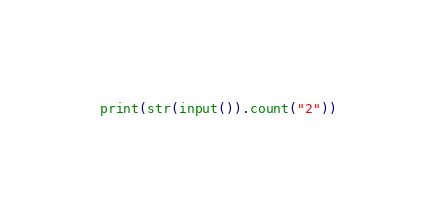<code> <loc_0><loc_0><loc_500><loc_500><_Python_>print(str(input()).count("2"))</code> 